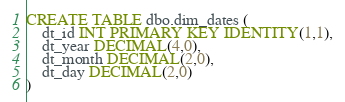Convert code to text. <code><loc_0><loc_0><loc_500><loc_500><_SQL_>CREATE TABLE dbo.dim_dates (
	dt_id INT PRIMARY KEY IDENTITY(1,1),
	dt_year DECIMAL(4,0),
	dt_month DECIMAL(2,0),
	dt_day DECIMAL(2,0)
)</code> 